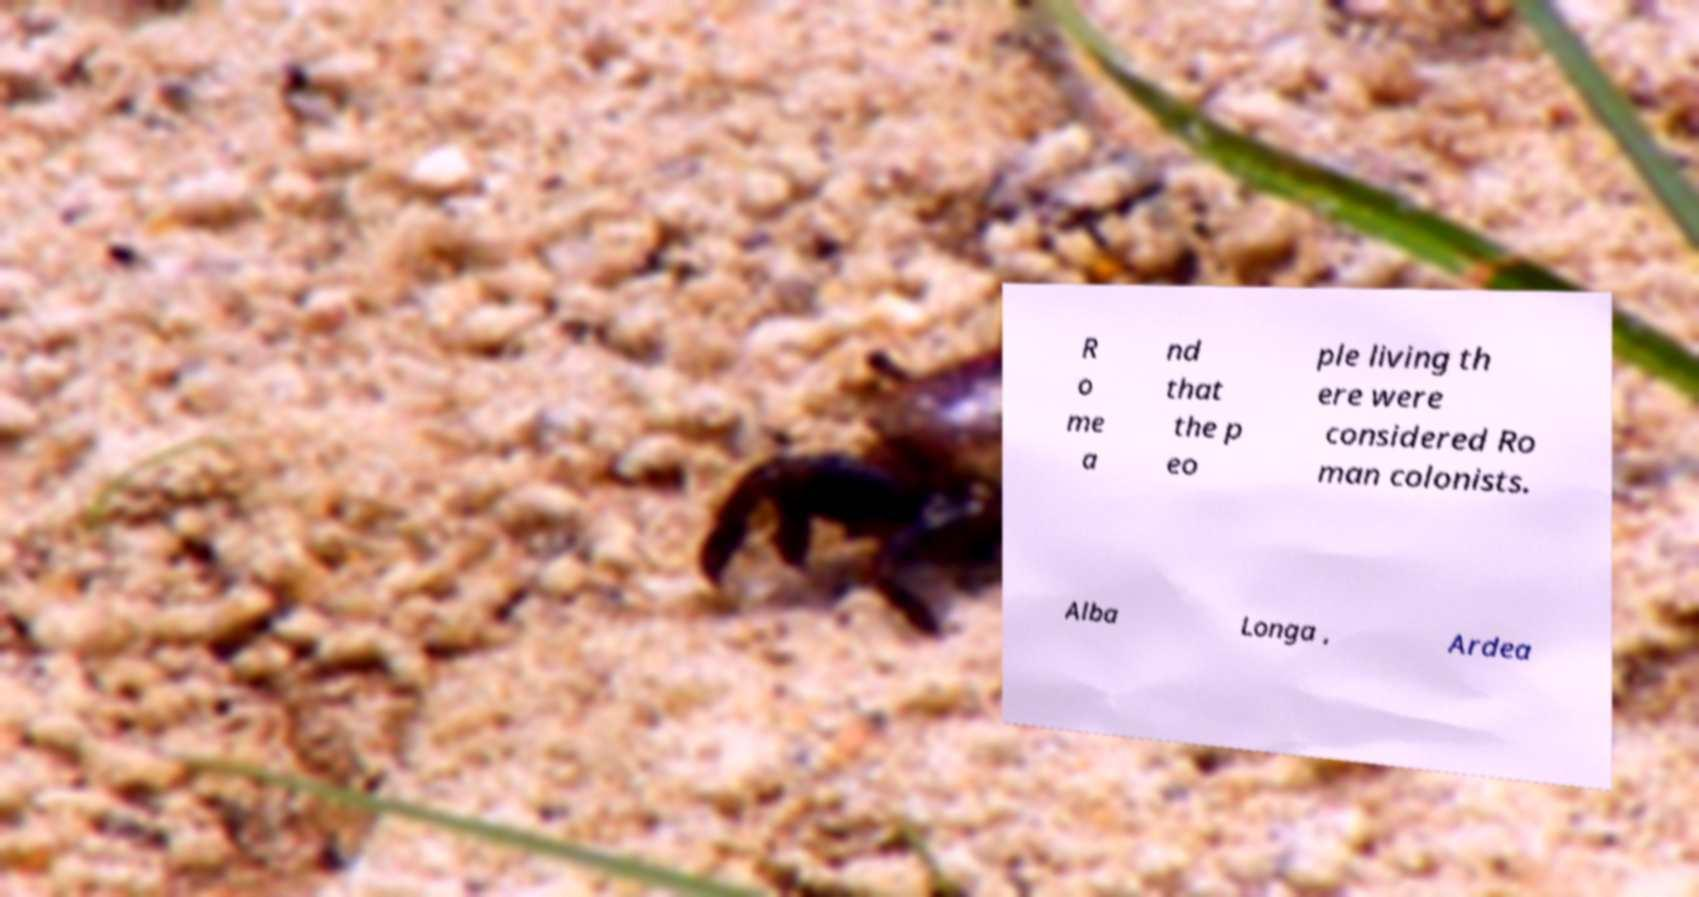Could you assist in decoding the text presented in this image and type it out clearly? R o me a nd that the p eo ple living th ere were considered Ro man colonists. Alba Longa , Ardea 